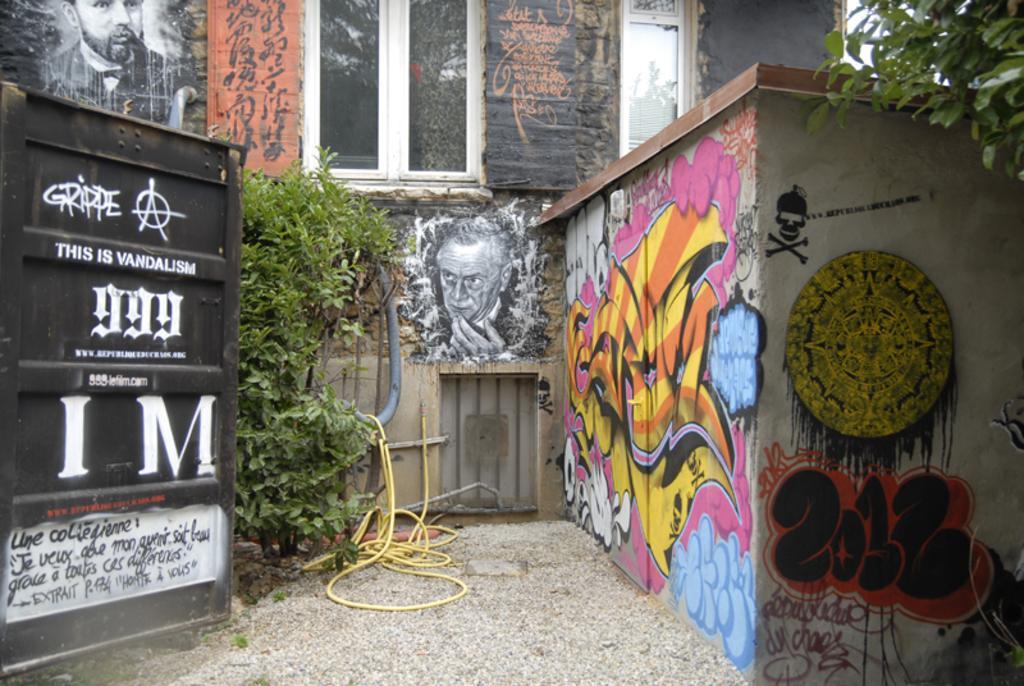Please provide a concise description of this image. In this image we can see walls on which pictures are painted, gate, plant, pipeline and ground. 